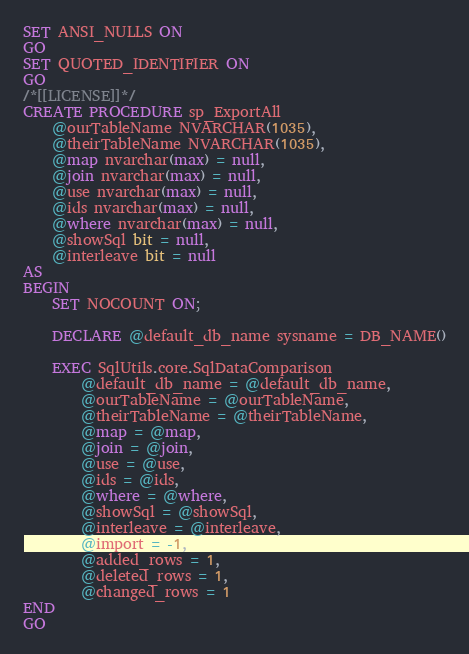<code> <loc_0><loc_0><loc_500><loc_500><_SQL_>SET ANSI_NULLS ON
GO
SET QUOTED_IDENTIFIER ON
GO
/*[[LICENSE]]*/
CREATE PROCEDURE sp_ExportAll
	@ourTableName NVARCHAR(1035),
	@theirTableName NVARCHAR(1035),
	@map nvarchar(max) = null,
	@join nvarchar(max) = null,
	@use nvarchar(max) = null,
	@ids nvarchar(max) = null,
	@where nvarchar(max) = null,
	@showSql bit = null,
	@interleave bit = null
AS
BEGIN
	SET NOCOUNT ON;

	DECLARE @default_db_name sysname = DB_NAME()

	EXEC SqlUtils.core.SqlDataComparison
		@default_db_name = @default_db_name,
		@ourTableName = @ourTableName,
		@theirTableName = @theirTableName,
		@map = @map,
		@join = @join,
		@use = @use,
		@ids = @ids,
		@where = @where,
		@showSql = @showSql,
		@interleave = @interleave,
		@import = -1,
		@added_rows = 1,
		@deleted_rows = 1,
		@changed_rows = 1
END
GO
</code> 